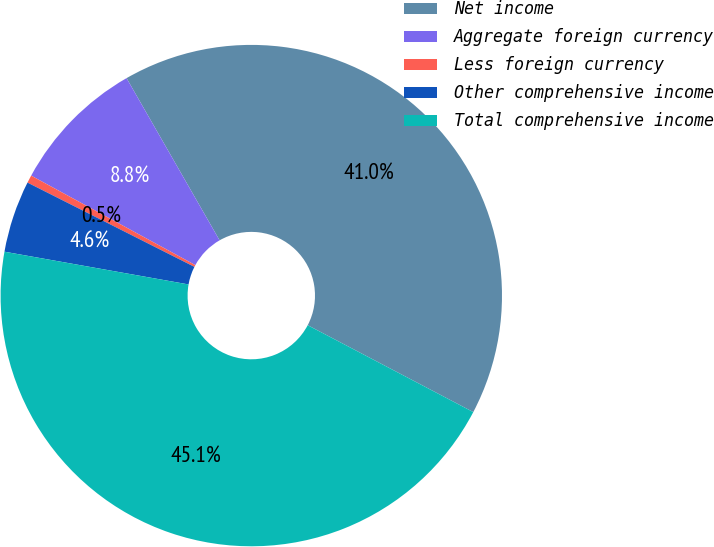Convert chart. <chart><loc_0><loc_0><loc_500><loc_500><pie_chart><fcel>Net income<fcel>Aggregate foreign currency<fcel>Less foreign currency<fcel>Other comprehensive income<fcel>Total comprehensive income<nl><fcel>40.98%<fcel>8.77%<fcel>0.5%<fcel>4.64%<fcel>45.11%<nl></chart> 